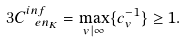<formula> <loc_0><loc_0><loc_500><loc_500>3 C ^ { i n f } _ { \ e n _ { K } } & = \max _ { v | \infty } \{ c _ { v } ^ { - 1 } \} \geq 1 .</formula> 